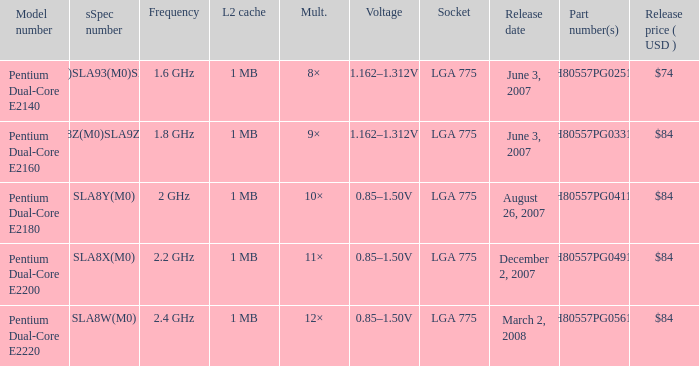What's the voltage for the pentium dual-core e2140? 1.162–1.312V. 